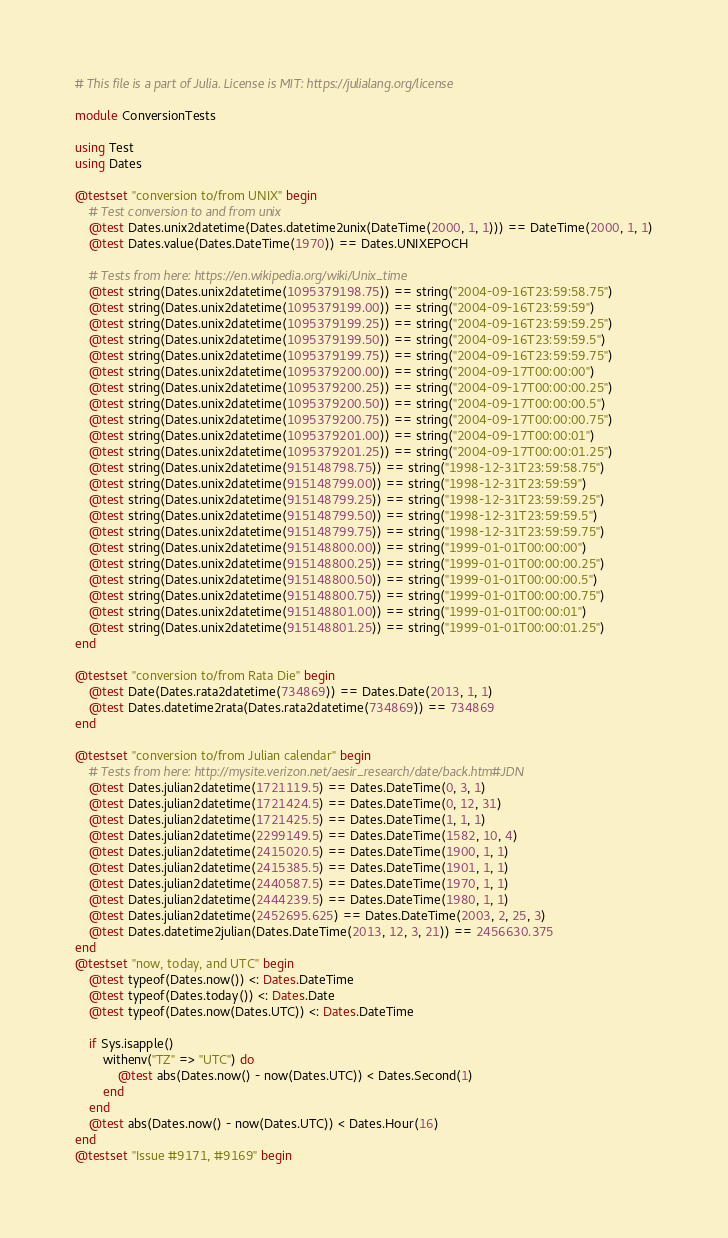Convert code to text. <code><loc_0><loc_0><loc_500><loc_500><_Julia_># This file is a part of Julia. License is MIT: https://julialang.org/license

module ConversionTests

using Test
using Dates

@testset "conversion to/from UNIX" begin
    # Test conversion to and from unix
    @test Dates.unix2datetime(Dates.datetime2unix(DateTime(2000, 1, 1))) == DateTime(2000, 1, 1)
    @test Dates.value(Dates.DateTime(1970)) == Dates.UNIXEPOCH

    # Tests from here: https://en.wikipedia.org/wiki/Unix_time
    @test string(Dates.unix2datetime(1095379198.75)) == string("2004-09-16T23:59:58.75")
    @test string(Dates.unix2datetime(1095379199.00)) == string("2004-09-16T23:59:59")
    @test string(Dates.unix2datetime(1095379199.25)) == string("2004-09-16T23:59:59.25")
    @test string(Dates.unix2datetime(1095379199.50)) == string("2004-09-16T23:59:59.5")
    @test string(Dates.unix2datetime(1095379199.75)) == string("2004-09-16T23:59:59.75")
    @test string(Dates.unix2datetime(1095379200.00)) == string("2004-09-17T00:00:00")
    @test string(Dates.unix2datetime(1095379200.25)) == string("2004-09-17T00:00:00.25")
    @test string(Dates.unix2datetime(1095379200.50)) == string("2004-09-17T00:00:00.5")
    @test string(Dates.unix2datetime(1095379200.75)) == string("2004-09-17T00:00:00.75")
    @test string(Dates.unix2datetime(1095379201.00)) == string("2004-09-17T00:00:01")
    @test string(Dates.unix2datetime(1095379201.25)) == string("2004-09-17T00:00:01.25")
    @test string(Dates.unix2datetime(915148798.75)) == string("1998-12-31T23:59:58.75")
    @test string(Dates.unix2datetime(915148799.00)) == string("1998-12-31T23:59:59")
    @test string(Dates.unix2datetime(915148799.25)) == string("1998-12-31T23:59:59.25")
    @test string(Dates.unix2datetime(915148799.50)) == string("1998-12-31T23:59:59.5")
    @test string(Dates.unix2datetime(915148799.75)) == string("1998-12-31T23:59:59.75")
    @test string(Dates.unix2datetime(915148800.00)) == string("1999-01-01T00:00:00")
    @test string(Dates.unix2datetime(915148800.25)) == string("1999-01-01T00:00:00.25")
    @test string(Dates.unix2datetime(915148800.50)) == string("1999-01-01T00:00:00.5")
    @test string(Dates.unix2datetime(915148800.75)) == string("1999-01-01T00:00:00.75")
    @test string(Dates.unix2datetime(915148801.00)) == string("1999-01-01T00:00:01")
    @test string(Dates.unix2datetime(915148801.25)) == string("1999-01-01T00:00:01.25")
end

@testset "conversion to/from Rata Die" begin
    @test Date(Dates.rata2datetime(734869)) == Dates.Date(2013, 1, 1)
    @test Dates.datetime2rata(Dates.rata2datetime(734869)) == 734869
end

@testset "conversion to/from Julian calendar" begin
    # Tests from here: http://mysite.verizon.net/aesir_research/date/back.htm#JDN
    @test Dates.julian2datetime(1721119.5) == Dates.DateTime(0, 3, 1)
    @test Dates.julian2datetime(1721424.5) == Dates.DateTime(0, 12, 31)
    @test Dates.julian2datetime(1721425.5) == Dates.DateTime(1, 1, 1)
    @test Dates.julian2datetime(2299149.5) == Dates.DateTime(1582, 10, 4)
    @test Dates.julian2datetime(2415020.5) == Dates.DateTime(1900, 1, 1)
    @test Dates.julian2datetime(2415385.5) == Dates.DateTime(1901, 1, 1)
    @test Dates.julian2datetime(2440587.5) == Dates.DateTime(1970, 1, 1)
    @test Dates.julian2datetime(2444239.5) == Dates.DateTime(1980, 1, 1)
    @test Dates.julian2datetime(2452695.625) == Dates.DateTime(2003, 2, 25, 3)
    @test Dates.datetime2julian(Dates.DateTime(2013, 12, 3, 21)) == 2456630.375
end
@testset "now, today, and UTC" begin
    @test typeof(Dates.now()) <: Dates.DateTime
    @test typeof(Dates.today()) <: Dates.Date
    @test typeof(Dates.now(Dates.UTC)) <: Dates.DateTime

    if Sys.isapple()
        withenv("TZ" => "UTC") do
            @test abs(Dates.now() - now(Dates.UTC)) < Dates.Second(1)
        end
    end
    @test abs(Dates.now() - now(Dates.UTC)) < Dates.Hour(16)
end
@testset "Issue #9171, #9169" begin</code> 